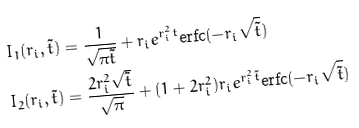<formula> <loc_0><loc_0><loc_500><loc_500>I _ { 1 } ( r _ { i } , \tilde { t } ) & = \frac { 1 } { \sqrt { \pi \tilde { t } } } + r _ { i } e ^ { r _ { i } ^ { 2 } t } \text {erfc} ( - r _ { i } \sqrt { \tilde { t } } ) \\ I _ { 2 } ( r _ { i } , \tilde { t } ) & = \frac { 2 r _ { i } ^ { 2 } \sqrt { \tilde { t } } } { \sqrt { \pi } } + ( 1 + 2 r _ { i } ^ { 2 } ) r _ { i } e ^ { r _ { i } ^ { 2 } \tilde { t } } \text {erfc} ( - r _ { i } \sqrt { \tilde { t } } )</formula> 